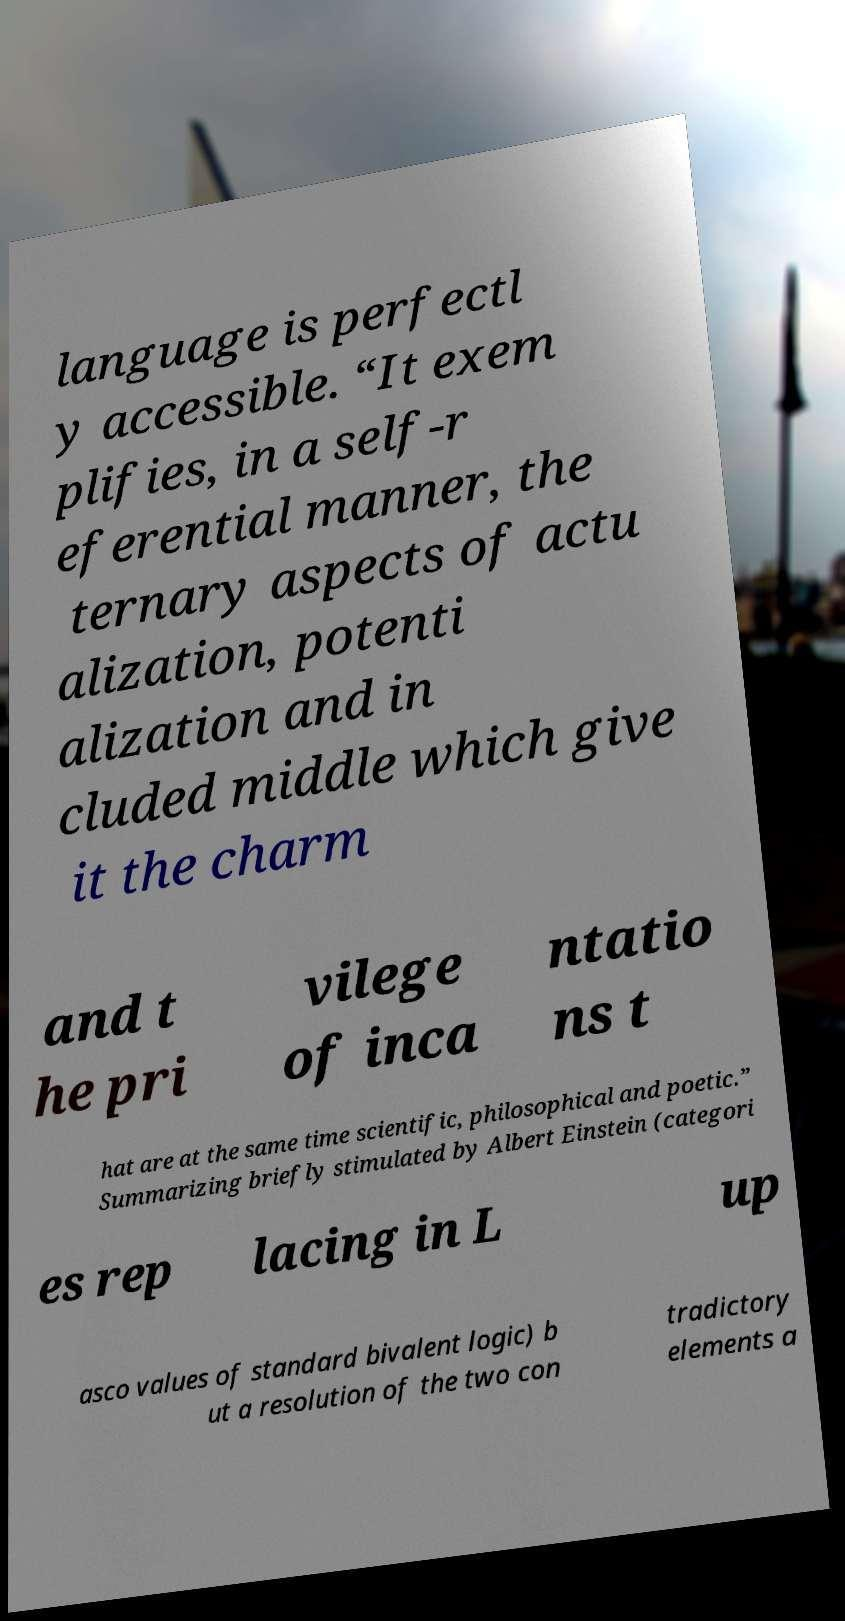There's text embedded in this image that I need extracted. Can you transcribe it verbatim? language is perfectl y accessible. “It exem plifies, in a self-r eferential manner, the ternary aspects of actu alization, potenti alization and in cluded middle which give it the charm and t he pri vilege of inca ntatio ns t hat are at the same time scientific, philosophical and poetic.” Summarizing briefly stimulated by Albert Einstein (categori es rep lacing in L up asco values of standard bivalent logic) b ut a resolution of the two con tradictory elements a 